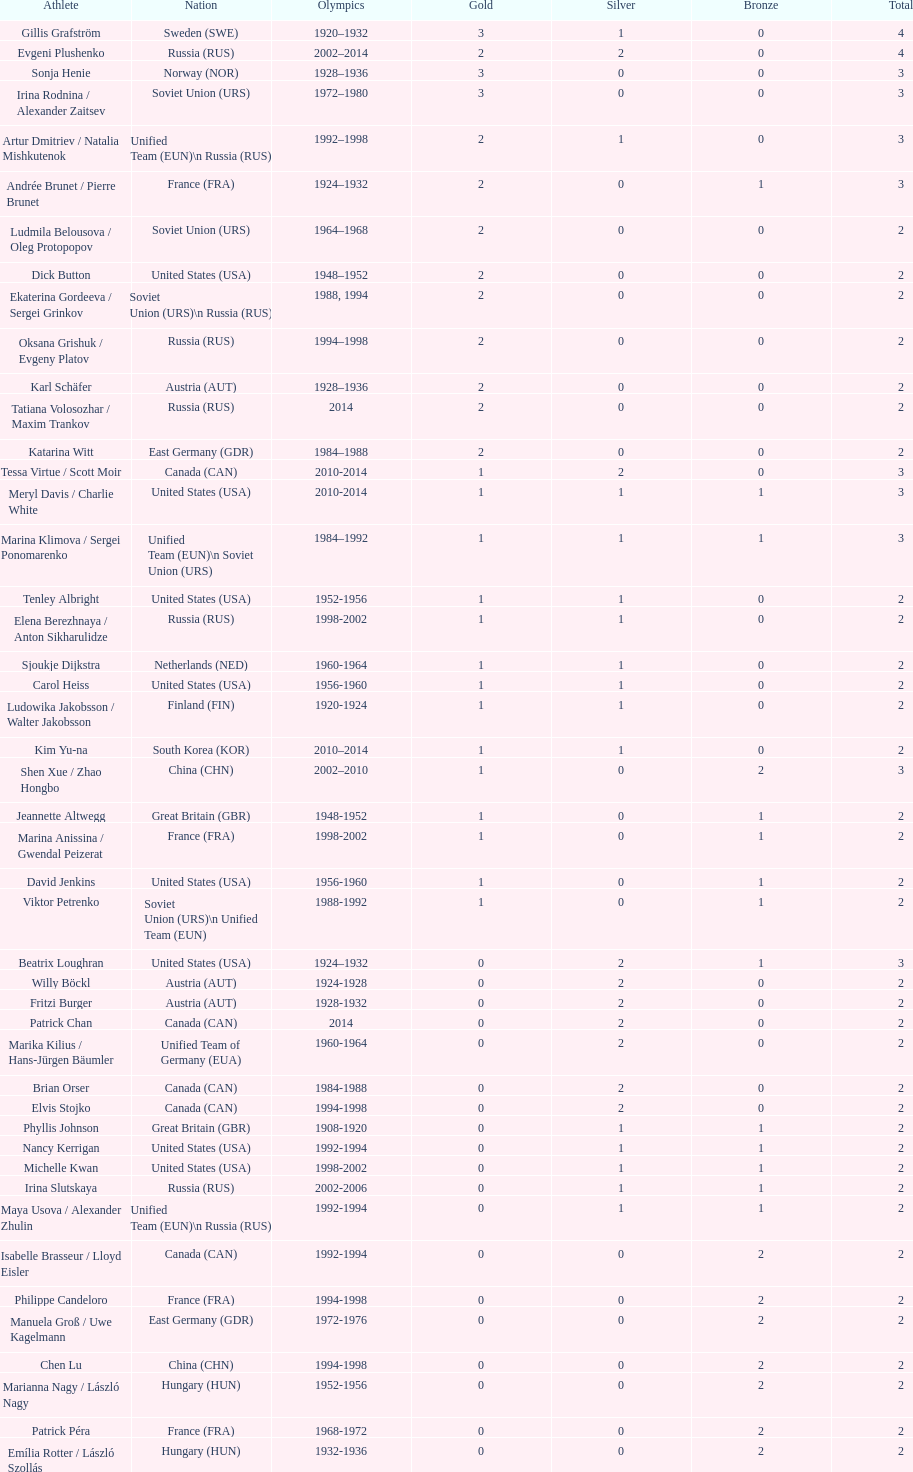How many more silver medals did gillis grafström have compared to sonja henie? 1. 